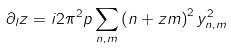<formula> <loc_0><loc_0><loc_500><loc_500>\partial _ { l } z = i 2 \pi ^ { 2 } p \sum _ { n , m } \left ( n + z m \right ) ^ { 2 } y _ { n , m } ^ { 2 }</formula> 